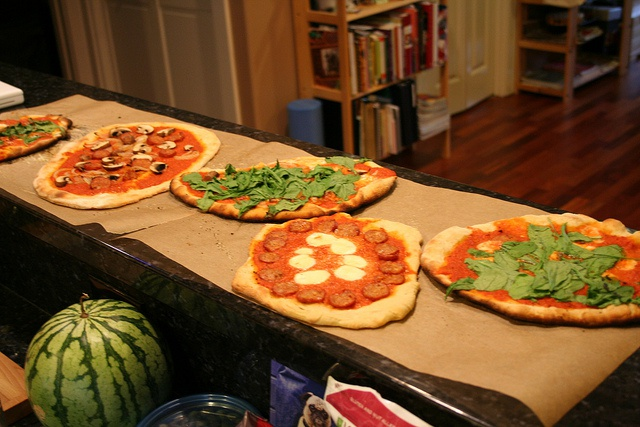Describe the objects in this image and their specific colors. I can see dining table in black, tan, red, and maroon tones, pizza in black, red, and olive tones, pizza in black, red, khaki, gold, and orange tones, pizza in black, red, and orange tones, and pizza in black, olive, red, and orange tones in this image. 